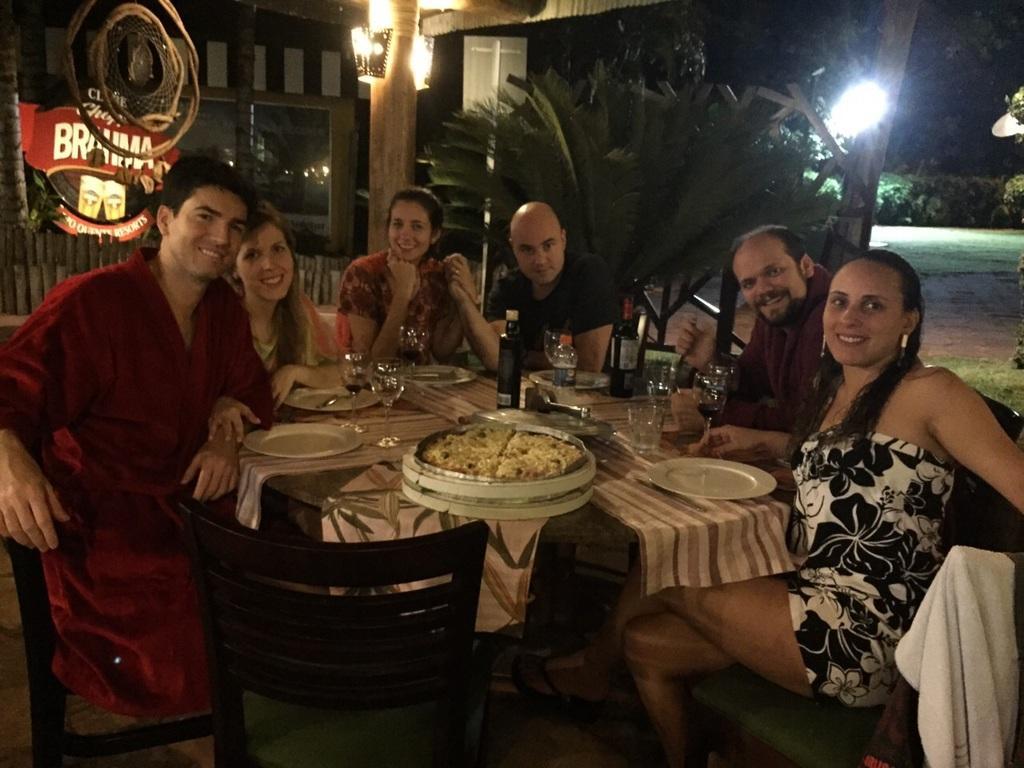How would you summarize this image in a sentence or two? In this image, there are six persons sitting on the chair at dining table on which plates, food items, glasses, bottles and son kept. In the background right, there are trees and plants visible and a focus light is visible. In the left top, a restaurant wall is visible. This image is taken in a lawn area during night time. 